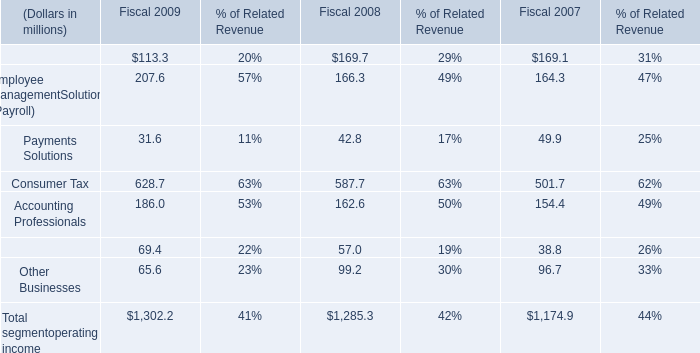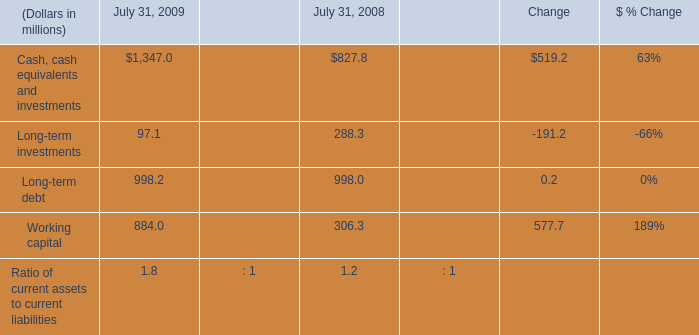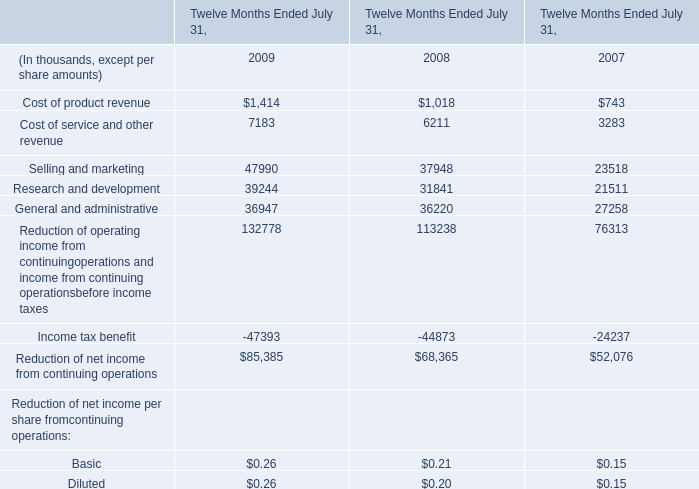What's the sum of Cash, cash equivalents and investments of July 31, 2009, and Income tax benefit of Twelve Months Ended July 31, 2007 ? 
Computations: (1347.0 + 24237.0)
Answer: 25584.0. 